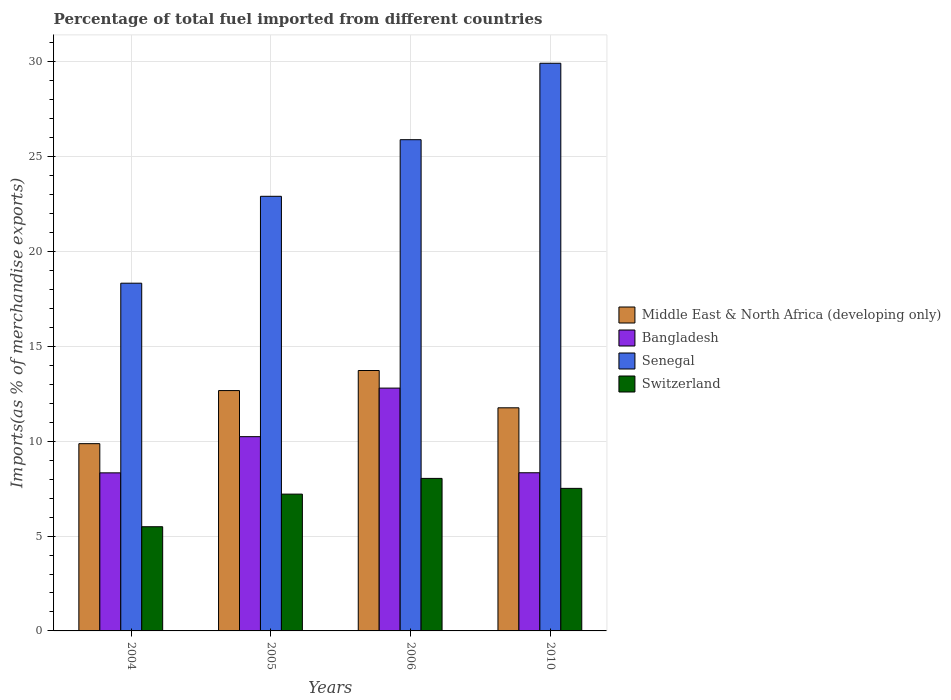How many different coloured bars are there?
Provide a succinct answer. 4. Are the number of bars per tick equal to the number of legend labels?
Provide a succinct answer. Yes. Are the number of bars on each tick of the X-axis equal?
Offer a terse response. Yes. How many bars are there on the 4th tick from the left?
Keep it short and to the point. 4. How many bars are there on the 2nd tick from the right?
Offer a terse response. 4. In how many cases, is the number of bars for a given year not equal to the number of legend labels?
Your response must be concise. 0. What is the percentage of imports to different countries in Switzerland in 2004?
Keep it short and to the point. 5.49. Across all years, what is the maximum percentage of imports to different countries in Bangladesh?
Make the answer very short. 12.8. Across all years, what is the minimum percentage of imports to different countries in Switzerland?
Provide a short and direct response. 5.49. In which year was the percentage of imports to different countries in Senegal maximum?
Offer a very short reply. 2010. What is the total percentage of imports to different countries in Senegal in the graph?
Provide a short and direct response. 97.07. What is the difference between the percentage of imports to different countries in Middle East & North Africa (developing only) in 2006 and that in 2010?
Offer a terse response. 1.97. What is the difference between the percentage of imports to different countries in Senegal in 2010 and the percentage of imports to different countries in Middle East & North Africa (developing only) in 2005?
Your answer should be compact. 17.26. What is the average percentage of imports to different countries in Middle East & North Africa (developing only) per year?
Make the answer very short. 12.01. In the year 2010, what is the difference between the percentage of imports to different countries in Middle East & North Africa (developing only) and percentage of imports to different countries in Bangladesh?
Make the answer very short. 3.42. In how many years, is the percentage of imports to different countries in Senegal greater than 6 %?
Make the answer very short. 4. What is the ratio of the percentage of imports to different countries in Bangladesh in 2005 to that in 2010?
Ensure brevity in your answer.  1.23. Is the difference between the percentage of imports to different countries in Middle East & North Africa (developing only) in 2005 and 2010 greater than the difference between the percentage of imports to different countries in Bangladesh in 2005 and 2010?
Your answer should be very brief. No. What is the difference between the highest and the second highest percentage of imports to different countries in Switzerland?
Give a very brief answer. 0.53. What is the difference between the highest and the lowest percentage of imports to different countries in Switzerland?
Provide a short and direct response. 2.55. Is the sum of the percentage of imports to different countries in Switzerland in 2004 and 2010 greater than the maximum percentage of imports to different countries in Middle East & North Africa (developing only) across all years?
Give a very brief answer. No. Is it the case that in every year, the sum of the percentage of imports to different countries in Senegal and percentage of imports to different countries in Middle East & North Africa (developing only) is greater than the sum of percentage of imports to different countries in Switzerland and percentage of imports to different countries in Bangladesh?
Offer a terse response. Yes. What does the 4th bar from the left in 2006 represents?
Ensure brevity in your answer.  Switzerland. What does the 4th bar from the right in 2004 represents?
Offer a terse response. Middle East & North Africa (developing only). How many bars are there?
Provide a short and direct response. 16. Are all the bars in the graph horizontal?
Offer a terse response. No. How many years are there in the graph?
Your answer should be very brief. 4. What is the difference between two consecutive major ticks on the Y-axis?
Keep it short and to the point. 5. Does the graph contain grids?
Give a very brief answer. Yes. Where does the legend appear in the graph?
Give a very brief answer. Center right. What is the title of the graph?
Give a very brief answer. Percentage of total fuel imported from different countries. Does "Angola" appear as one of the legend labels in the graph?
Ensure brevity in your answer.  No. What is the label or title of the Y-axis?
Provide a short and direct response. Imports(as % of merchandise exports). What is the Imports(as % of merchandise exports) in Middle East & North Africa (developing only) in 2004?
Ensure brevity in your answer.  9.87. What is the Imports(as % of merchandise exports) in Bangladesh in 2004?
Offer a terse response. 8.33. What is the Imports(as % of merchandise exports) of Senegal in 2004?
Offer a very short reply. 18.33. What is the Imports(as % of merchandise exports) in Switzerland in 2004?
Your answer should be compact. 5.49. What is the Imports(as % of merchandise exports) in Middle East & North Africa (developing only) in 2005?
Offer a terse response. 12.67. What is the Imports(as % of merchandise exports) of Bangladesh in 2005?
Give a very brief answer. 10.24. What is the Imports(as % of merchandise exports) of Senegal in 2005?
Make the answer very short. 22.91. What is the Imports(as % of merchandise exports) in Switzerland in 2005?
Ensure brevity in your answer.  7.21. What is the Imports(as % of merchandise exports) in Middle East & North Africa (developing only) in 2006?
Make the answer very short. 13.73. What is the Imports(as % of merchandise exports) of Bangladesh in 2006?
Your response must be concise. 12.8. What is the Imports(as % of merchandise exports) of Senegal in 2006?
Your answer should be very brief. 25.9. What is the Imports(as % of merchandise exports) in Switzerland in 2006?
Make the answer very short. 8.04. What is the Imports(as % of merchandise exports) of Middle East & North Africa (developing only) in 2010?
Keep it short and to the point. 11.76. What is the Imports(as % of merchandise exports) of Bangladesh in 2010?
Your answer should be compact. 8.34. What is the Imports(as % of merchandise exports) in Senegal in 2010?
Provide a succinct answer. 29.93. What is the Imports(as % of merchandise exports) of Switzerland in 2010?
Keep it short and to the point. 7.52. Across all years, what is the maximum Imports(as % of merchandise exports) of Middle East & North Africa (developing only)?
Your answer should be compact. 13.73. Across all years, what is the maximum Imports(as % of merchandise exports) of Bangladesh?
Provide a short and direct response. 12.8. Across all years, what is the maximum Imports(as % of merchandise exports) of Senegal?
Keep it short and to the point. 29.93. Across all years, what is the maximum Imports(as % of merchandise exports) of Switzerland?
Offer a very short reply. 8.04. Across all years, what is the minimum Imports(as % of merchandise exports) in Middle East & North Africa (developing only)?
Your response must be concise. 9.87. Across all years, what is the minimum Imports(as % of merchandise exports) of Bangladesh?
Offer a terse response. 8.33. Across all years, what is the minimum Imports(as % of merchandise exports) in Senegal?
Your answer should be very brief. 18.33. Across all years, what is the minimum Imports(as % of merchandise exports) of Switzerland?
Provide a short and direct response. 5.49. What is the total Imports(as % of merchandise exports) of Middle East & North Africa (developing only) in the graph?
Give a very brief answer. 48.04. What is the total Imports(as % of merchandise exports) in Bangladesh in the graph?
Ensure brevity in your answer.  39.71. What is the total Imports(as % of merchandise exports) of Senegal in the graph?
Provide a succinct answer. 97.07. What is the total Imports(as % of merchandise exports) in Switzerland in the graph?
Ensure brevity in your answer.  28.26. What is the difference between the Imports(as % of merchandise exports) of Middle East & North Africa (developing only) in 2004 and that in 2005?
Give a very brief answer. -2.8. What is the difference between the Imports(as % of merchandise exports) of Bangladesh in 2004 and that in 2005?
Keep it short and to the point. -1.91. What is the difference between the Imports(as % of merchandise exports) in Senegal in 2004 and that in 2005?
Your answer should be compact. -4.58. What is the difference between the Imports(as % of merchandise exports) in Switzerland in 2004 and that in 2005?
Offer a terse response. -1.72. What is the difference between the Imports(as % of merchandise exports) in Middle East & North Africa (developing only) in 2004 and that in 2006?
Make the answer very short. -3.86. What is the difference between the Imports(as % of merchandise exports) in Bangladesh in 2004 and that in 2006?
Offer a very short reply. -4.47. What is the difference between the Imports(as % of merchandise exports) of Senegal in 2004 and that in 2006?
Offer a very short reply. -7.57. What is the difference between the Imports(as % of merchandise exports) in Switzerland in 2004 and that in 2006?
Your answer should be very brief. -2.55. What is the difference between the Imports(as % of merchandise exports) in Middle East & North Africa (developing only) in 2004 and that in 2010?
Provide a short and direct response. -1.89. What is the difference between the Imports(as % of merchandise exports) of Bangladesh in 2004 and that in 2010?
Provide a succinct answer. -0. What is the difference between the Imports(as % of merchandise exports) in Senegal in 2004 and that in 2010?
Your answer should be compact. -11.6. What is the difference between the Imports(as % of merchandise exports) in Switzerland in 2004 and that in 2010?
Ensure brevity in your answer.  -2.02. What is the difference between the Imports(as % of merchandise exports) in Middle East & North Africa (developing only) in 2005 and that in 2006?
Your answer should be compact. -1.06. What is the difference between the Imports(as % of merchandise exports) of Bangladesh in 2005 and that in 2006?
Your answer should be compact. -2.56. What is the difference between the Imports(as % of merchandise exports) of Senegal in 2005 and that in 2006?
Offer a very short reply. -2.99. What is the difference between the Imports(as % of merchandise exports) of Switzerland in 2005 and that in 2006?
Give a very brief answer. -0.83. What is the difference between the Imports(as % of merchandise exports) in Middle East & North Africa (developing only) in 2005 and that in 2010?
Your response must be concise. 0.91. What is the difference between the Imports(as % of merchandise exports) in Bangladesh in 2005 and that in 2010?
Give a very brief answer. 1.9. What is the difference between the Imports(as % of merchandise exports) in Senegal in 2005 and that in 2010?
Your response must be concise. -7.01. What is the difference between the Imports(as % of merchandise exports) in Switzerland in 2005 and that in 2010?
Provide a short and direct response. -0.3. What is the difference between the Imports(as % of merchandise exports) of Middle East & North Africa (developing only) in 2006 and that in 2010?
Provide a succinct answer. 1.97. What is the difference between the Imports(as % of merchandise exports) in Bangladesh in 2006 and that in 2010?
Your answer should be very brief. 4.46. What is the difference between the Imports(as % of merchandise exports) in Senegal in 2006 and that in 2010?
Your response must be concise. -4.03. What is the difference between the Imports(as % of merchandise exports) in Switzerland in 2006 and that in 2010?
Offer a terse response. 0.53. What is the difference between the Imports(as % of merchandise exports) of Middle East & North Africa (developing only) in 2004 and the Imports(as % of merchandise exports) of Bangladesh in 2005?
Your answer should be compact. -0.37. What is the difference between the Imports(as % of merchandise exports) of Middle East & North Africa (developing only) in 2004 and the Imports(as % of merchandise exports) of Senegal in 2005?
Make the answer very short. -13.04. What is the difference between the Imports(as % of merchandise exports) of Middle East & North Africa (developing only) in 2004 and the Imports(as % of merchandise exports) of Switzerland in 2005?
Your answer should be very brief. 2.66. What is the difference between the Imports(as % of merchandise exports) in Bangladesh in 2004 and the Imports(as % of merchandise exports) in Senegal in 2005?
Provide a succinct answer. -14.58. What is the difference between the Imports(as % of merchandise exports) of Bangladesh in 2004 and the Imports(as % of merchandise exports) of Switzerland in 2005?
Your response must be concise. 1.12. What is the difference between the Imports(as % of merchandise exports) of Senegal in 2004 and the Imports(as % of merchandise exports) of Switzerland in 2005?
Give a very brief answer. 11.12. What is the difference between the Imports(as % of merchandise exports) of Middle East & North Africa (developing only) in 2004 and the Imports(as % of merchandise exports) of Bangladesh in 2006?
Give a very brief answer. -2.93. What is the difference between the Imports(as % of merchandise exports) of Middle East & North Africa (developing only) in 2004 and the Imports(as % of merchandise exports) of Senegal in 2006?
Your answer should be compact. -16.03. What is the difference between the Imports(as % of merchandise exports) of Middle East & North Africa (developing only) in 2004 and the Imports(as % of merchandise exports) of Switzerland in 2006?
Offer a terse response. 1.83. What is the difference between the Imports(as % of merchandise exports) of Bangladesh in 2004 and the Imports(as % of merchandise exports) of Senegal in 2006?
Provide a short and direct response. -17.56. What is the difference between the Imports(as % of merchandise exports) of Bangladesh in 2004 and the Imports(as % of merchandise exports) of Switzerland in 2006?
Provide a succinct answer. 0.29. What is the difference between the Imports(as % of merchandise exports) in Senegal in 2004 and the Imports(as % of merchandise exports) in Switzerland in 2006?
Give a very brief answer. 10.29. What is the difference between the Imports(as % of merchandise exports) in Middle East & North Africa (developing only) in 2004 and the Imports(as % of merchandise exports) in Bangladesh in 2010?
Provide a succinct answer. 1.53. What is the difference between the Imports(as % of merchandise exports) of Middle East & North Africa (developing only) in 2004 and the Imports(as % of merchandise exports) of Senegal in 2010?
Your answer should be very brief. -20.05. What is the difference between the Imports(as % of merchandise exports) in Middle East & North Africa (developing only) in 2004 and the Imports(as % of merchandise exports) in Switzerland in 2010?
Your response must be concise. 2.36. What is the difference between the Imports(as % of merchandise exports) in Bangladesh in 2004 and the Imports(as % of merchandise exports) in Senegal in 2010?
Give a very brief answer. -21.59. What is the difference between the Imports(as % of merchandise exports) in Bangladesh in 2004 and the Imports(as % of merchandise exports) in Switzerland in 2010?
Your answer should be very brief. 0.82. What is the difference between the Imports(as % of merchandise exports) of Senegal in 2004 and the Imports(as % of merchandise exports) of Switzerland in 2010?
Make the answer very short. 10.82. What is the difference between the Imports(as % of merchandise exports) of Middle East & North Africa (developing only) in 2005 and the Imports(as % of merchandise exports) of Bangladesh in 2006?
Make the answer very short. -0.13. What is the difference between the Imports(as % of merchandise exports) of Middle East & North Africa (developing only) in 2005 and the Imports(as % of merchandise exports) of Senegal in 2006?
Your answer should be compact. -13.23. What is the difference between the Imports(as % of merchandise exports) in Middle East & North Africa (developing only) in 2005 and the Imports(as % of merchandise exports) in Switzerland in 2006?
Your answer should be very brief. 4.63. What is the difference between the Imports(as % of merchandise exports) in Bangladesh in 2005 and the Imports(as % of merchandise exports) in Senegal in 2006?
Your response must be concise. -15.66. What is the difference between the Imports(as % of merchandise exports) in Bangladesh in 2005 and the Imports(as % of merchandise exports) in Switzerland in 2006?
Keep it short and to the point. 2.2. What is the difference between the Imports(as % of merchandise exports) of Senegal in 2005 and the Imports(as % of merchandise exports) of Switzerland in 2006?
Your response must be concise. 14.87. What is the difference between the Imports(as % of merchandise exports) of Middle East & North Africa (developing only) in 2005 and the Imports(as % of merchandise exports) of Bangladesh in 2010?
Offer a terse response. 4.33. What is the difference between the Imports(as % of merchandise exports) of Middle East & North Africa (developing only) in 2005 and the Imports(as % of merchandise exports) of Senegal in 2010?
Offer a very short reply. -17.26. What is the difference between the Imports(as % of merchandise exports) of Middle East & North Africa (developing only) in 2005 and the Imports(as % of merchandise exports) of Switzerland in 2010?
Your answer should be compact. 5.16. What is the difference between the Imports(as % of merchandise exports) in Bangladesh in 2005 and the Imports(as % of merchandise exports) in Senegal in 2010?
Offer a very short reply. -19.69. What is the difference between the Imports(as % of merchandise exports) of Bangladesh in 2005 and the Imports(as % of merchandise exports) of Switzerland in 2010?
Your answer should be compact. 2.73. What is the difference between the Imports(as % of merchandise exports) in Senegal in 2005 and the Imports(as % of merchandise exports) in Switzerland in 2010?
Offer a terse response. 15.4. What is the difference between the Imports(as % of merchandise exports) in Middle East & North Africa (developing only) in 2006 and the Imports(as % of merchandise exports) in Bangladesh in 2010?
Your response must be concise. 5.39. What is the difference between the Imports(as % of merchandise exports) of Middle East & North Africa (developing only) in 2006 and the Imports(as % of merchandise exports) of Senegal in 2010?
Offer a very short reply. -16.2. What is the difference between the Imports(as % of merchandise exports) of Middle East & North Africa (developing only) in 2006 and the Imports(as % of merchandise exports) of Switzerland in 2010?
Your answer should be compact. 6.21. What is the difference between the Imports(as % of merchandise exports) of Bangladesh in 2006 and the Imports(as % of merchandise exports) of Senegal in 2010?
Make the answer very short. -17.13. What is the difference between the Imports(as % of merchandise exports) in Bangladesh in 2006 and the Imports(as % of merchandise exports) in Switzerland in 2010?
Keep it short and to the point. 5.29. What is the difference between the Imports(as % of merchandise exports) of Senegal in 2006 and the Imports(as % of merchandise exports) of Switzerland in 2010?
Your answer should be compact. 18.38. What is the average Imports(as % of merchandise exports) in Middle East & North Africa (developing only) per year?
Provide a succinct answer. 12.01. What is the average Imports(as % of merchandise exports) of Bangladesh per year?
Give a very brief answer. 9.93. What is the average Imports(as % of merchandise exports) of Senegal per year?
Keep it short and to the point. 24.27. What is the average Imports(as % of merchandise exports) of Switzerland per year?
Make the answer very short. 7.07. In the year 2004, what is the difference between the Imports(as % of merchandise exports) in Middle East & North Africa (developing only) and Imports(as % of merchandise exports) in Bangladesh?
Provide a short and direct response. 1.54. In the year 2004, what is the difference between the Imports(as % of merchandise exports) of Middle East & North Africa (developing only) and Imports(as % of merchandise exports) of Senegal?
Offer a terse response. -8.46. In the year 2004, what is the difference between the Imports(as % of merchandise exports) in Middle East & North Africa (developing only) and Imports(as % of merchandise exports) in Switzerland?
Give a very brief answer. 4.38. In the year 2004, what is the difference between the Imports(as % of merchandise exports) in Bangladesh and Imports(as % of merchandise exports) in Senegal?
Give a very brief answer. -10. In the year 2004, what is the difference between the Imports(as % of merchandise exports) of Bangladesh and Imports(as % of merchandise exports) of Switzerland?
Offer a very short reply. 2.84. In the year 2004, what is the difference between the Imports(as % of merchandise exports) of Senegal and Imports(as % of merchandise exports) of Switzerland?
Your response must be concise. 12.84. In the year 2005, what is the difference between the Imports(as % of merchandise exports) of Middle East & North Africa (developing only) and Imports(as % of merchandise exports) of Bangladesh?
Provide a short and direct response. 2.43. In the year 2005, what is the difference between the Imports(as % of merchandise exports) of Middle East & North Africa (developing only) and Imports(as % of merchandise exports) of Senegal?
Provide a short and direct response. -10.24. In the year 2005, what is the difference between the Imports(as % of merchandise exports) of Middle East & North Africa (developing only) and Imports(as % of merchandise exports) of Switzerland?
Provide a succinct answer. 5.46. In the year 2005, what is the difference between the Imports(as % of merchandise exports) in Bangladesh and Imports(as % of merchandise exports) in Senegal?
Your response must be concise. -12.67. In the year 2005, what is the difference between the Imports(as % of merchandise exports) of Bangladesh and Imports(as % of merchandise exports) of Switzerland?
Provide a succinct answer. 3.03. In the year 2005, what is the difference between the Imports(as % of merchandise exports) in Senegal and Imports(as % of merchandise exports) in Switzerland?
Provide a succinct answer. 15.7. In the year 2006, what is the difference between the Imports(as % of merchandise exports) in Middle East & North Africa (developing only) and Imports(as % of merchandise exports) in Bangladesh?
Ensure brevity in your answer.  0.93. In the year 2006, what is the difference between the Imports(as % of merchandise exports) in Middle East & North Africa (developing only) and Imports(as % of merchandise exports) in Senegal?
Your answer should be very brief. -12.17. In the year 2006, what is the difference between the Imports(as % of merchandise exports) in Middle East & North Africa (developing only) and Imports(as % of merchandise exports) in Switzerland?
Offer a very short reply. 5.69. In the year 2006, what is the difference between the Imports(as % of merchandise exports) of Bangladesh and Imports(as % of merchandise exports) of Senegal?
Make the answer very short. -13.1. In the year 2006, what is the difference between the Imports(as % of merchandise exports) in Bangladesh and Imports(as % of merchandise exports) in Switzerland?
Keep it short and to the point. 4.76. In the year 2006, what is the difference between the Imports(as % of merchandise exports) of Senegal and Imports(as % of merchandise exports) of Switzerland?
Your answer should be very brief. 17.86. In the year 2010, what is the difference between the Imports(as % of merchandise exports) in Middle East & North Africa (developing only) and Imports(as % of merchandise exports) in Bangladesh?
Give a very brief answer. 3.42. In the year 2010, what is the difference between the Imports(as % of merchandise exports) of Middle East & North Africa (developing only) and Imports(as % of merchandise exports) of Senegal?
Ensure brevity in your answer.  -18.16. In the year 2010, what is the difference between the Imports(as % of merchandise exports) in Middle East & North Africa (developing only) and Imports(as % of merchandise exports) in Switzerland?
Offer a very short reply. 4.25. In the year 2010, what is the difference between the Imports(as % of merchandise exports) of Bangladesh and Imports(as % of merchandise exports) of Senegal?
Your answer should be compact. -21.59. In the year 2010, what is the difference between the Imports(as % of merchandise exports) of Bangladesh and Imports(as % of merchandise exports) of Switzerland?
Keep it short and to the point. 0.82. In the year 2010, what is the difference between the Imports(as % of merchandise exports) in Senegal and Imports(as % of merchandise exports) in Switzerland?
Ensure brevity in your answer.  22.41. What is the ratio of the Imports(as % of merchandise exports) of Middle East & North Africa (developing only) in 2004 to that in 2005?
Provide a succinct answer. 0.78. What is the ratio of the Imports(as % of merchandise exports) of Bangladesh in 2004 to that in 2005?
Make the answer very short. 0.81. What is the ratio of the Imports(as % of merchandise exports) in Senegal in 2004 to that in 2005?
Ensure brevity in your answer.  0.8. What is the ratio of the Imports(as % of merchandise exports) of Switzerland in 2004 to that in 2005?
Provide a succinct answer. 0.76. What is the ratio of the Imports(as % of merchandise exports) of Middle East & North Africa (developing only) in 2004 to that in 2006?
Keep it short and to the point. 0.72. What is the ratio of the Imports(as % of merchandise exports) in Bangladesh in 2004 to that in 2006?
Your response must be concise. 0.65. What is the ratio of the Imports(as % of merchandise exports) of Senegal in 2004 to that in 2006?
Make the answer very short. 0.71. What is the ratio of the Imports(as % of merchandise exports) in Switzerland in 2004 to that in 2006?
Keep it short and to the point. 0.68. What is the ratio of the Imports(as % of merchandise exports) of Middle East & North Africa (developing only) in 2004 to that in 2010?
Your response must be concise. 0.84. What is the ratio of the Imports(as % of merchandise exports) in Bangladesh in 2004 to that in 2010?
Your answer should be very brief. 1. What is the ratio of the Imports(as % of merchandise exports) in Senegal in 2004 to that in 2010?
Ensure brevity in your answer.  0.61. What is the ratio of the Imports(as % of merchandise exports) in Switzerland in 2004 to that in 2010?
Keep it short and to the point. 0.73. What is the ratio of the Imports(as % of merchandise exports) in Middle East & North Africa (developing only) in 2005 to that in 2006?
Provide a succinct answer. 0.92. What is the ratio of the Imports(as % of merchandise exports) in Senegal in 2005 to that in 2006?
Your answer should be very brief. 0.88. What is the ratio of the Imports(as % of merchandise exports) of Switzerland in 2005 to that in 2006?
Ensure brevity in your answer.  0.9. What is the ratio of the Imports(as % of merchandise exports) of Middle East & North Africa (developing only) in 2005 to that in 2010?
Make the answer very short. 1.08. What is the ratio of the Imports(as % of merchandise exports) of Bangladesh in 2005 to that in 2010?
Provide a succinct answer. 1.23. What is the ratio of the Imports(as % of merchandise exports) of Senegal in 2005 to that in 2010?
Make the answer very short. 0.77. What is the ratio of the Imports(as % of merchandise exports) in Switzerland in 2005 to that in 2010?
Your answer should be very brief. 0.96. What is the ratio of the Imports(as % of merchandise exports) of Middle East & North Africa (developing only) in 2006 to that in 2010?
Keep it short and to the point. 1.17. What is the ratio of the Imports(as % of merchandise exports) in Bangladesh in 2006 to that in 2010?
Ensure brevity in your answer.  1.54. What is the ratio of the Imports(as % of merchandise exports) of Senegal in 2006 to that in 2010?
Keep it short and to the point. 0.87. What is the ratio of the Imports(as % of merchandise exports) of Switzerland in 2006 to that in 2010?
Give a very brief answer. 1.07. What is the difference between the highest and the second highest Imports(as % of merchandise exports) in Middle East & North Africa (developing only)?
Your response must be concise. 1.06. What is the difference between the highest and the second highest Imports(as % of merchandise exports) of Bangladesh?
Your answer should be compact. 2.56. What is the difference between the highest and the second highest Imports(as % of merchandise exports) of Senegal?
Ensure brevity in your answer.  4.03. What is the difference between the highest and the second highest Imports(as % of merchandise exports) in Switzerland?
Keep it short and to the point. 0.53. What is the difference between the highest and the lowest Imports(as % of merchandise exports) of Middle East & North Africa (developing only)?
Provide a short and direct response. 3.86. What is the difference between the highest and the lowest Imports(as % of merchandise exports) in Bangladesh?
Ensure brevity in your answer.  4.47. What is the difference between the highest and the lowest Imports(as % of merchandise exports) of Senegal?
Your response must be concise. 11.6. What is the difference between the highest and the lowest Imports(as % of merchandise exports) in Switzerland?
Make the answer very short. 2.55. 